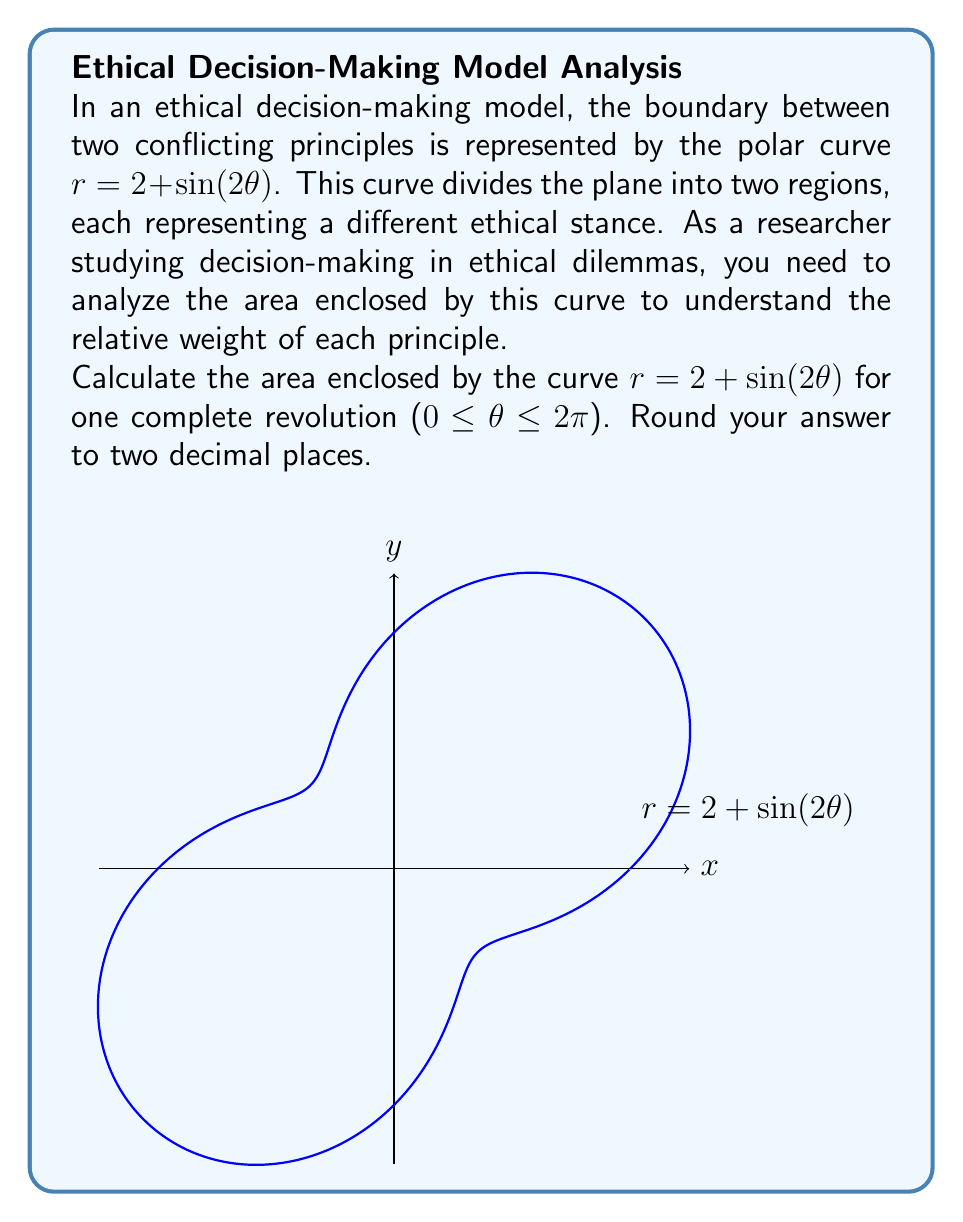What is the answer to this math problem? To find the area enclosed by the polar curve, we'll use the formula:

$$A = \frac{1}{2}\int_{0}^{2\pi} r^2(\theta) d\theta$$

1) First, we need to square the given function:
   $$r^2 = (2 + \sin(2\theta))^2 = 4 + 4\sin(2\theta) + \sin^2(2\theta)$$

2) Now, we can set up our integral:
   $$A = \frac{1}{2}\int_{0}^{2\pi} (4 + 4\sin(2\theta) + \sin^2(2\theta)) d\theta$$

3) Let's integrate each term separately:
   a) $\int_{0}^{2\pi} 4 d\theta = 4\theta \Big|_{0}^{2\pi} = 8\pi$
   
   b) $\int_{0}^{2\pi} 4\sin(2\theta) d\theta = -2\cos(2\theta) \Big|_{0}^{2\pi} = 0$
   
   c) For $\int_{0}^{2\pi} \sin^2(2\theta) d\theta$, we can use the identity $\sin^2(x) = \frac{1}{2}(1-\cos(2x))$:
      $$\int_{0}^{2\pi} \sin^2(2\theta) d\theta = \int_{0}^{2\pi} \frac{1}{2}(1-\cos(4\theta)) d\theta = \frac{1}{2}\theta - \frac{1}{8}\sin(4\theta) \Big|_{0}^{2\pi} = \pi$$

4) Adding these results:
   $$A = \frac{1}{2}(8\pi + 0 + \pi) = \frac{9\pi}{2}$$

5) Converting to a decimal and rounding to two places:
   $$A \approx 14.14$$
Answer: 14.14 square units 